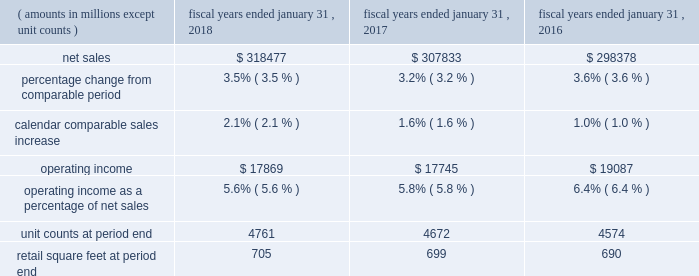Continued investments in ecommerce and technology .
The increase in operating expenses as a percentage of net sales for fiscal 2017 was partially offset by the impact of store closures in the fourth quarter of fiscal 2016 .
Membership and other income was relatively flat for fiscal 2018 and increased $ 1.0 billion a0for fiscal 2017 , when compared to the same period in the previous fiscal year .
While fiscal 2018 included a $ 387 million gain from the sale of suburbia , a $ 47 million gain from a land sale , higher recycling income from our sustainability efforts and higher membership income from increased plus member penetration at sam's club , these gains were less than gains recognized in fiscal 2017 .
Fiscal 2017 included a $ 535 million gain from the sale of our yihaodian business and a $ 194 million gain from the sale of shopping malls in chile .
For fiscal 2018 , loss on extinguishment of debt was a0$ 3.1 billion , due to the early extinguishment of long-term debt which allowed us to retire higher rate debt to reduce interest expense in future periods .
Our effective income tax rate was 30.4% ( 30.4 % ) for fiscal 2018 and 30.3% ( 30.3 % ) for both fiscal 2017 and 2016 .
Although relatively consistent year-over-year , our effective income tax rate may fluctuate from period to period as a result of factors including changes in our assessment of certain tax contingencies , valuation allowances , changes in tax laws , outcomes of administrative audits , the impact of discrete items and the mix of earnings among our u.s .
Operations and international operations .
The reconciliation from the u.s .
Statutory rate to the effective income tax rates for fiscal 2018 , 2017 and 2016 is presented in note 9 in the "notes to consolidated financial statements" and describes the impact of the enactment of the tax cuts and jobs act of 2017 ( the "tax act" ) to the fiscal 2018 effective income tax rate .
As a result of the factors discussed above , we reported $ 10.5 billion and $ 14.3 billion of consolidated net income for fiscal 2018 and 2017 , respectively , which represents a decrease of $ 3.8 billion and $ 0.8 billion for fiscal 2018 and 2017 , respectively , when compared to the previous fiscal year .
Diluted net income per common share attributable to walmart ( "eps" ) was $ 3.28 and $ 4.38 for fiscal 2018 and 2017 , respectively .
Walmart u.s .
Segment .
Net sales for the walmart u.s .
Segment increased $ 10.6 billion or 3.5% ( 3.5 % ) and $ 9.5 billion or 3.2% ( 3.2 % ) for fiscal 2018 and 2017 , respectively , when compared to the previous fiscal year .
The increases in net sales were primarily due to increases in comparable store sales of 2.1% ( 2.1 % ) and 1.6% ( 1.6 % ) for fiscal 2018 and 2017 , respectively , and year-over-year growth in retail square feet of 0.7% ( 0.7 % ) and 1.4% ( 1.4 % ) for fiscal 2018 and 2017 , respectively .
Additionally , for fiscal 2018 , sales generated from ecommerce acquisitions further contributed to the year-over-year increase .
Gross profit rate decreased 24 basis points for fiscal 2018 and increased 24 basis points for fiscal 2017 , when compared to the previous fiscal year .
For fiscal 2018 , the decrease was primarily due to strategic price investments and the mix impact from ecommerce .
Partially offsetting the negative factors for fiscal 2018 was the positive impact of savings from procuring merchandise .
For fiscal 2017 , the increase in gross profit rate was primarily due to improved margin in food and consumables , including the impact of savings in procuring merchandise and lower transportation expense from lower fuel costs .
Operating expenses as a percentage of segment net sales was relatively flat for fiscal 2018 and increased 101 basis points for fiscal 2017 , when compared to the previous fiscal year .
Fiscal 2018 and fiscal 2017 included charges related to discontinued real estate projects of $ 244 million and $ 249 million , respectively .
For fiscal 2017 , the increase was primarily driven by an increase in wage expense due to the investment in the associate wage structure ; the charge related to discontinued real estate projects ; and investments in digital retail and technology .
The increase in operating expenses as a percentage of segment net sales for fiscal 2017 was partially offset by the impact of store closures in fiscal 2016 .
As a result of the factors discussed above , segment operating income increased $ 124 million for fiscal 2018 and decreased $ 1.3 billion for fiscal 2017 , respectively. .
In fiscal 2017 what was the ratio of the gain from the sale of the yihaodian business to the gain from the sale of shopping malls in chile .? 
Computations: (535 / 194)
Answer: 2.75773. 